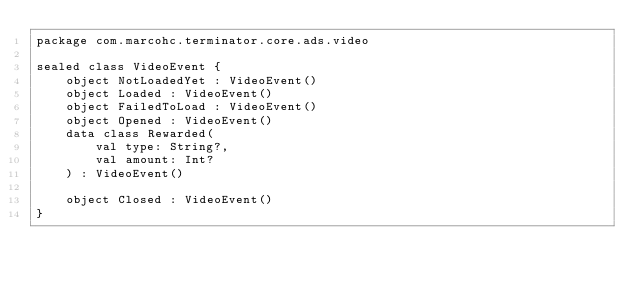<code> <loc_0><loc_0><loc_500><loc_500><_Kotlin_>package com.marcohc.terminator.core.ads.video

sealed class VideoEvent {
    object NotLoadedYet : VideoEvent()
    object Loaded : VideoEvent()
    object FailedToLoad : VideoEvent()
    object Opened : VideoEvent()
    data class Rewarded(
        val type: String?,
        val amount: Int?
    ) : VideoEvent()

    object Closed : VideoEvent()
}
</code> 